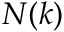Convert formula to latex. <formula><loc_0><loc_0><loc_500><loc_500>N ( k )</formula> 